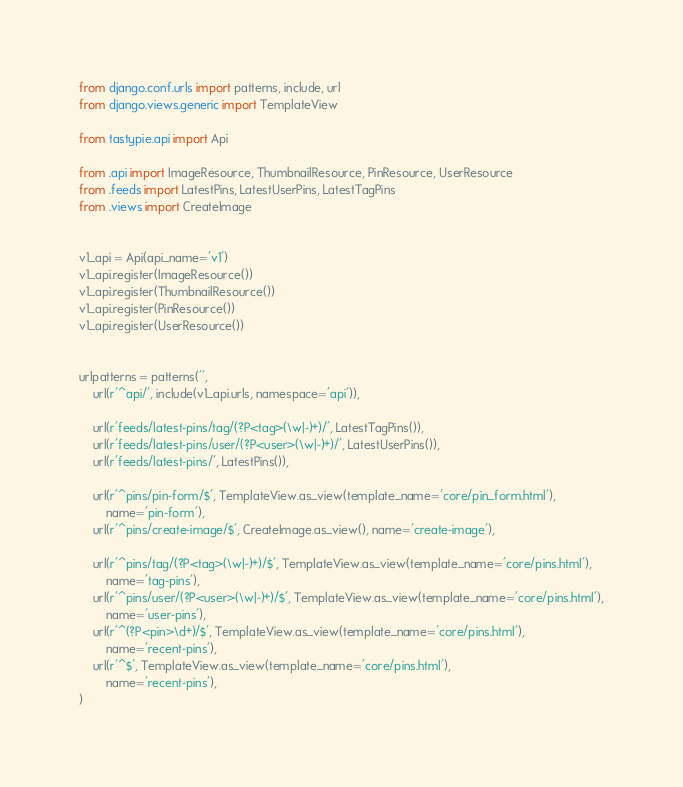Convert code to text. <code><loc_0><loc_0><loc_500><loc_500><_Python_>from django.conf.urls import patterns, include, url
from django.views.generic import TemplateView

from tastypie.api import Api

from .api import ImageResource, ThumbnailResource, PinResource, UserResource
from .feeds import LatestPins, LatestUserPins, LatestTagPins
from .views import CreateImage


v1_api = Api(api_name='v1')
v1_api.register(ImageResource())
v1_api.register(ThumbnailResource())
v1_api.register(PinResource())
v1_api.register(UserResource())


urlpatterns = patterns('',
    url(r'^api/', include(v1_api.urls, namespace='api')),

    url(r'feeds/latest-pins/tag/(?P<tag>(\w|-)+)/', LatestTagPins()),
    url(r'feeds/latest-pins/user/(?P<user>(\w|-)+)/', LatestUserPins()),
    url(r'feeds/latest-pins/', LatestPins()),

    url(r'^pins/pin-form/$', TemplateView.as_view(template_name='core/pin_form.html'),
        name='pin-form'),
    url(r'^pins/create-image/$', CreateImage.as_view(), name='create-image'),

    url(r'^pins/tag/(?P<tag>(\w|-)+)/$', TemplateView.as_view(template_name='core/pins.html'),
        name='tag-pins'),
    url(r'^pins/user/(?P<user>(\w|-)+)/$', TemplateView.as_view(template_name='core/pins.html'),
        name='user-pins'),
    url(r'^(?P<pin>\d+)/$', TemplateView.as_view(template_name='core/pins.html'),
        name='recent-pins'),
    url(r'^$', TemplateView.as_view(template_name='core/pins.html'),
        name='recent-pins'),
)
</code> 